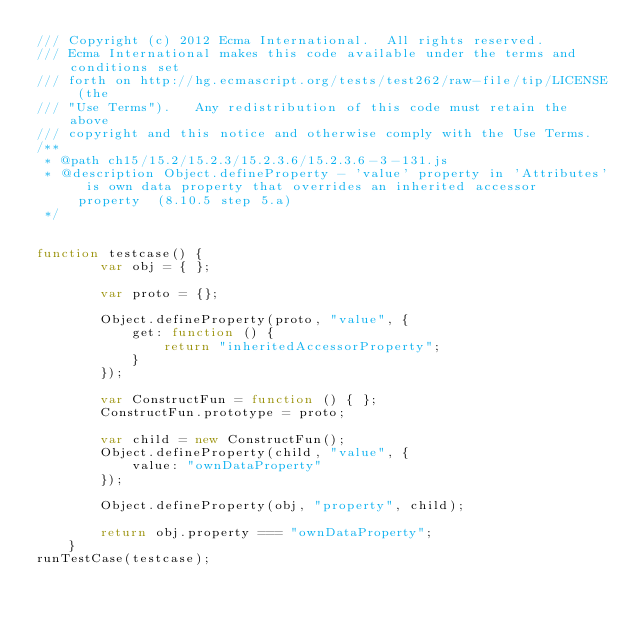<code> <loc_0><loc_0><loc_500><loc_500><_JavaScript_>/// Copyright (c) 2012 Ecma International.  All rights reserved. 
/// Ecma International makes this code available under the terms and conditions set
/// forth on http://hg.ecmascript.org/tests/test262/raw-file/tip/LICENSE (the 
/// "Use Terms").   Any redistribution of this code must retain the above 
/// copyright and this notice and otherwise comply with the Use Terms.
/**
 * @path ch15/15.2/15.2.3/15.2.3.6/15.2.3.6-3-131.js
 * @description Object.defineProperty - 'value' property in 'Attributes' is own data property that overrides an inherited accessor property  (8.10.5 step 5.a)
 */


function testcase() {
        var obj = { };

        var proto = {};

        Object.defineProperty(proto, "value", {
            get: function () {
                return "inheritedAccessorProperty";
            }
        });

        var ConstructFun = function () { };
        ConstructFun.prototype = proto;

        var child = new ConstructFun();
        Object.defineProperty(child, "value", {
            value: "ownDataProperty"
        });

        Object.defineProperty(obj, "property", child);

        return obj.property === "ownDataProperty";
    }
runTestCase(testcase);
</code> 